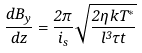<formula> <loc_0><loc_0><loc_500><loc_500>\frac { d B _ { y } } { d z } = \frac { 2 \pi } { i _ { s } } \sqrt { \frac { 2 \eta k T ^ { * } } { l ^ { 3 } \tau t } }</formula> 